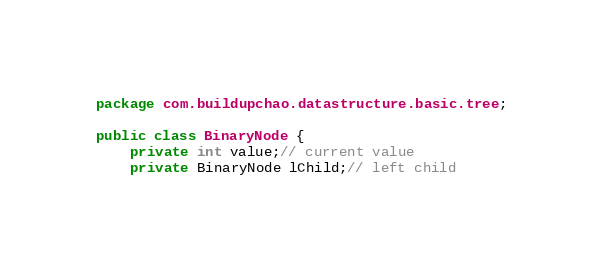<code> <loc_0><loc_0><loc_500><loc_500><_Java_>package com.buildupchao.datastructure.basic.tree;

public class BinaryNode {
	private int value;// current value
	private BinaryNode lChild;// left child</code> 